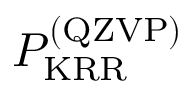Convert formula to latex. <formula><loc_0><loc_0><loc_500><loc_500>P _ { K R R } ^ { ( Q Z V P ) }</formula> 